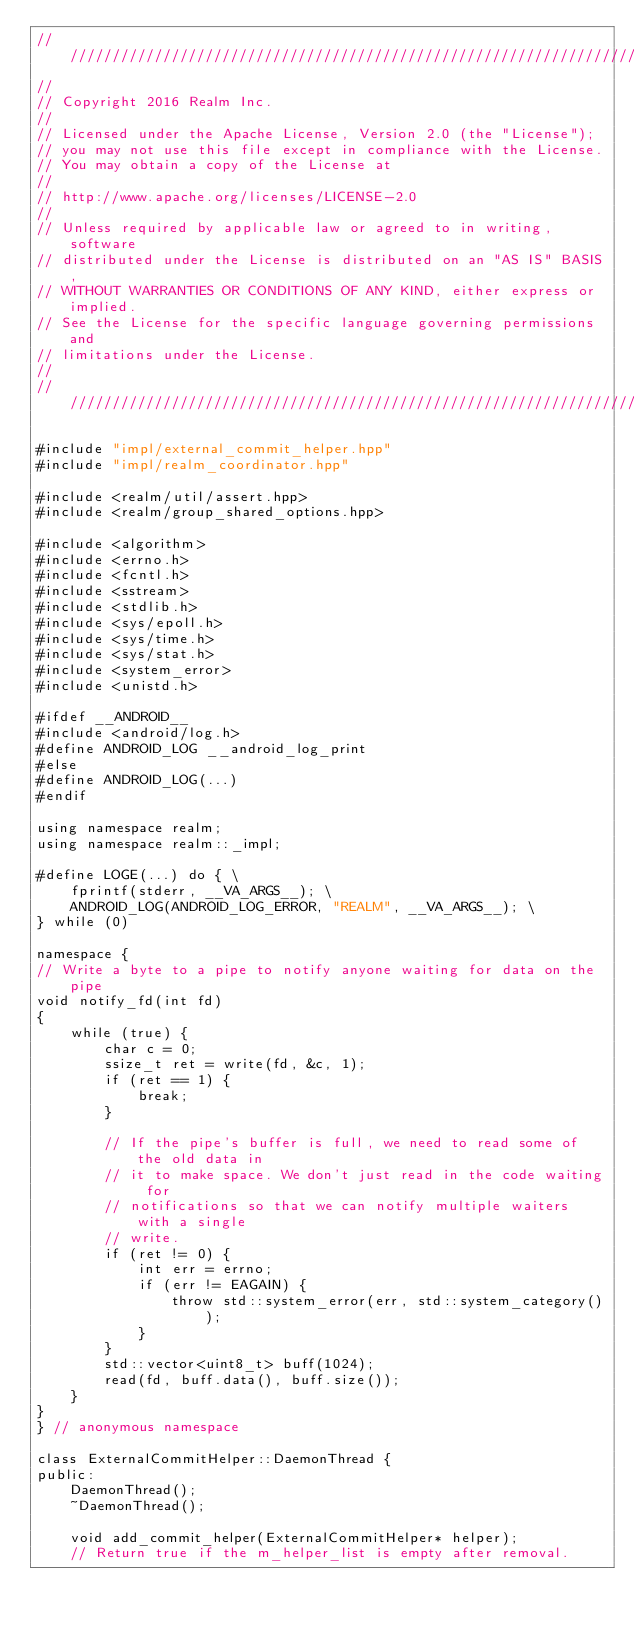<code> <loc_0><loc_0><loc_500><loc_500><_C++_>////////////////////////////////////////////////////////////////////////////
//
// Copyright 2016 Realm Inc.
//
// Licensed under the Apache License, Version 2.0 (the "License");
// you may not use this file except in compliance with the License.
// You may obtain a copy of the License at
//
// http://www.apache.org/licenses/LICENSE-2.0
//
// Unless required by applicable law or agreed to in writing, software
// distributed under the License is distributed on an "AS IS" BASIS,
// WITHOUT WARRANTIES OR CONDITIONS OF ANY KIND, either express or implied.
// See the License for the specific language governing permissions and
// limitations under the License.
//
////////////////////////////////////////////////////////////////////////////

#include "impl/external_commit_helper.hpp"
#include "impl/realm_coordinator.hpp"

#include <realm/util/assert.hpp>
#include <realm/group_shared_options.hpp>

#include <algorithm>
#include <errno.h>
#include <fcntl.h>
#include <sstream>
#include <stdlib.h>
#include <sys/epoll.h>
#include <sys/time.h>
#include <sys/stat.h>
#include <system_error>
#include <unistd.h>

#ifdef __ANDROID__
#include <android/log.h>
#define ANDROID_LOG __android_log_print
#else
#define ANDROID_LOG(...)
#endif

using namespace realm;
using namespace realm::_impl;

#define LOGE(...) do { \
    fprintf(stderr, __VA_ARGS__); \
    ANDROID_LOG(ANDROID_LOG_ERROR, "REALM", __VA_ARGS__); \
} while (0)

namespace {
// Write a byte to a pipe to notify anyone waiting for data on the pipe
void notify_fd(int fd)
{
    while (true) {
        char c = 0;
        ssize_t ret = write(fd, &c, 1);
        if (ret == 1) {
            break;
        }

        // If the pipe's buffer is full, we need to read some of the old data in
        // it to make space. We don't just read in the code waiting for
        // notifications so that we can notify multiple waiters with a single
        // write.
        if (ret != 0) {
            int err = errno;
            if (err != EAGAIN) {
                throw std::system_error(err, std::system_category());
            }
        }
        std::vector<uint8_t> buff(1024);
        read(fd, buff.data(), buff.size());
    }
}
} // anonymous namespace

class ExternalCommitHelper::DaemonThread {
public:
    DaemonThread();
    ~DaemonThread();

    void add_commit_helper(ExternalCommitHelper* helper);
    // Return true if the m_helper_list is empty after removal.</code> 